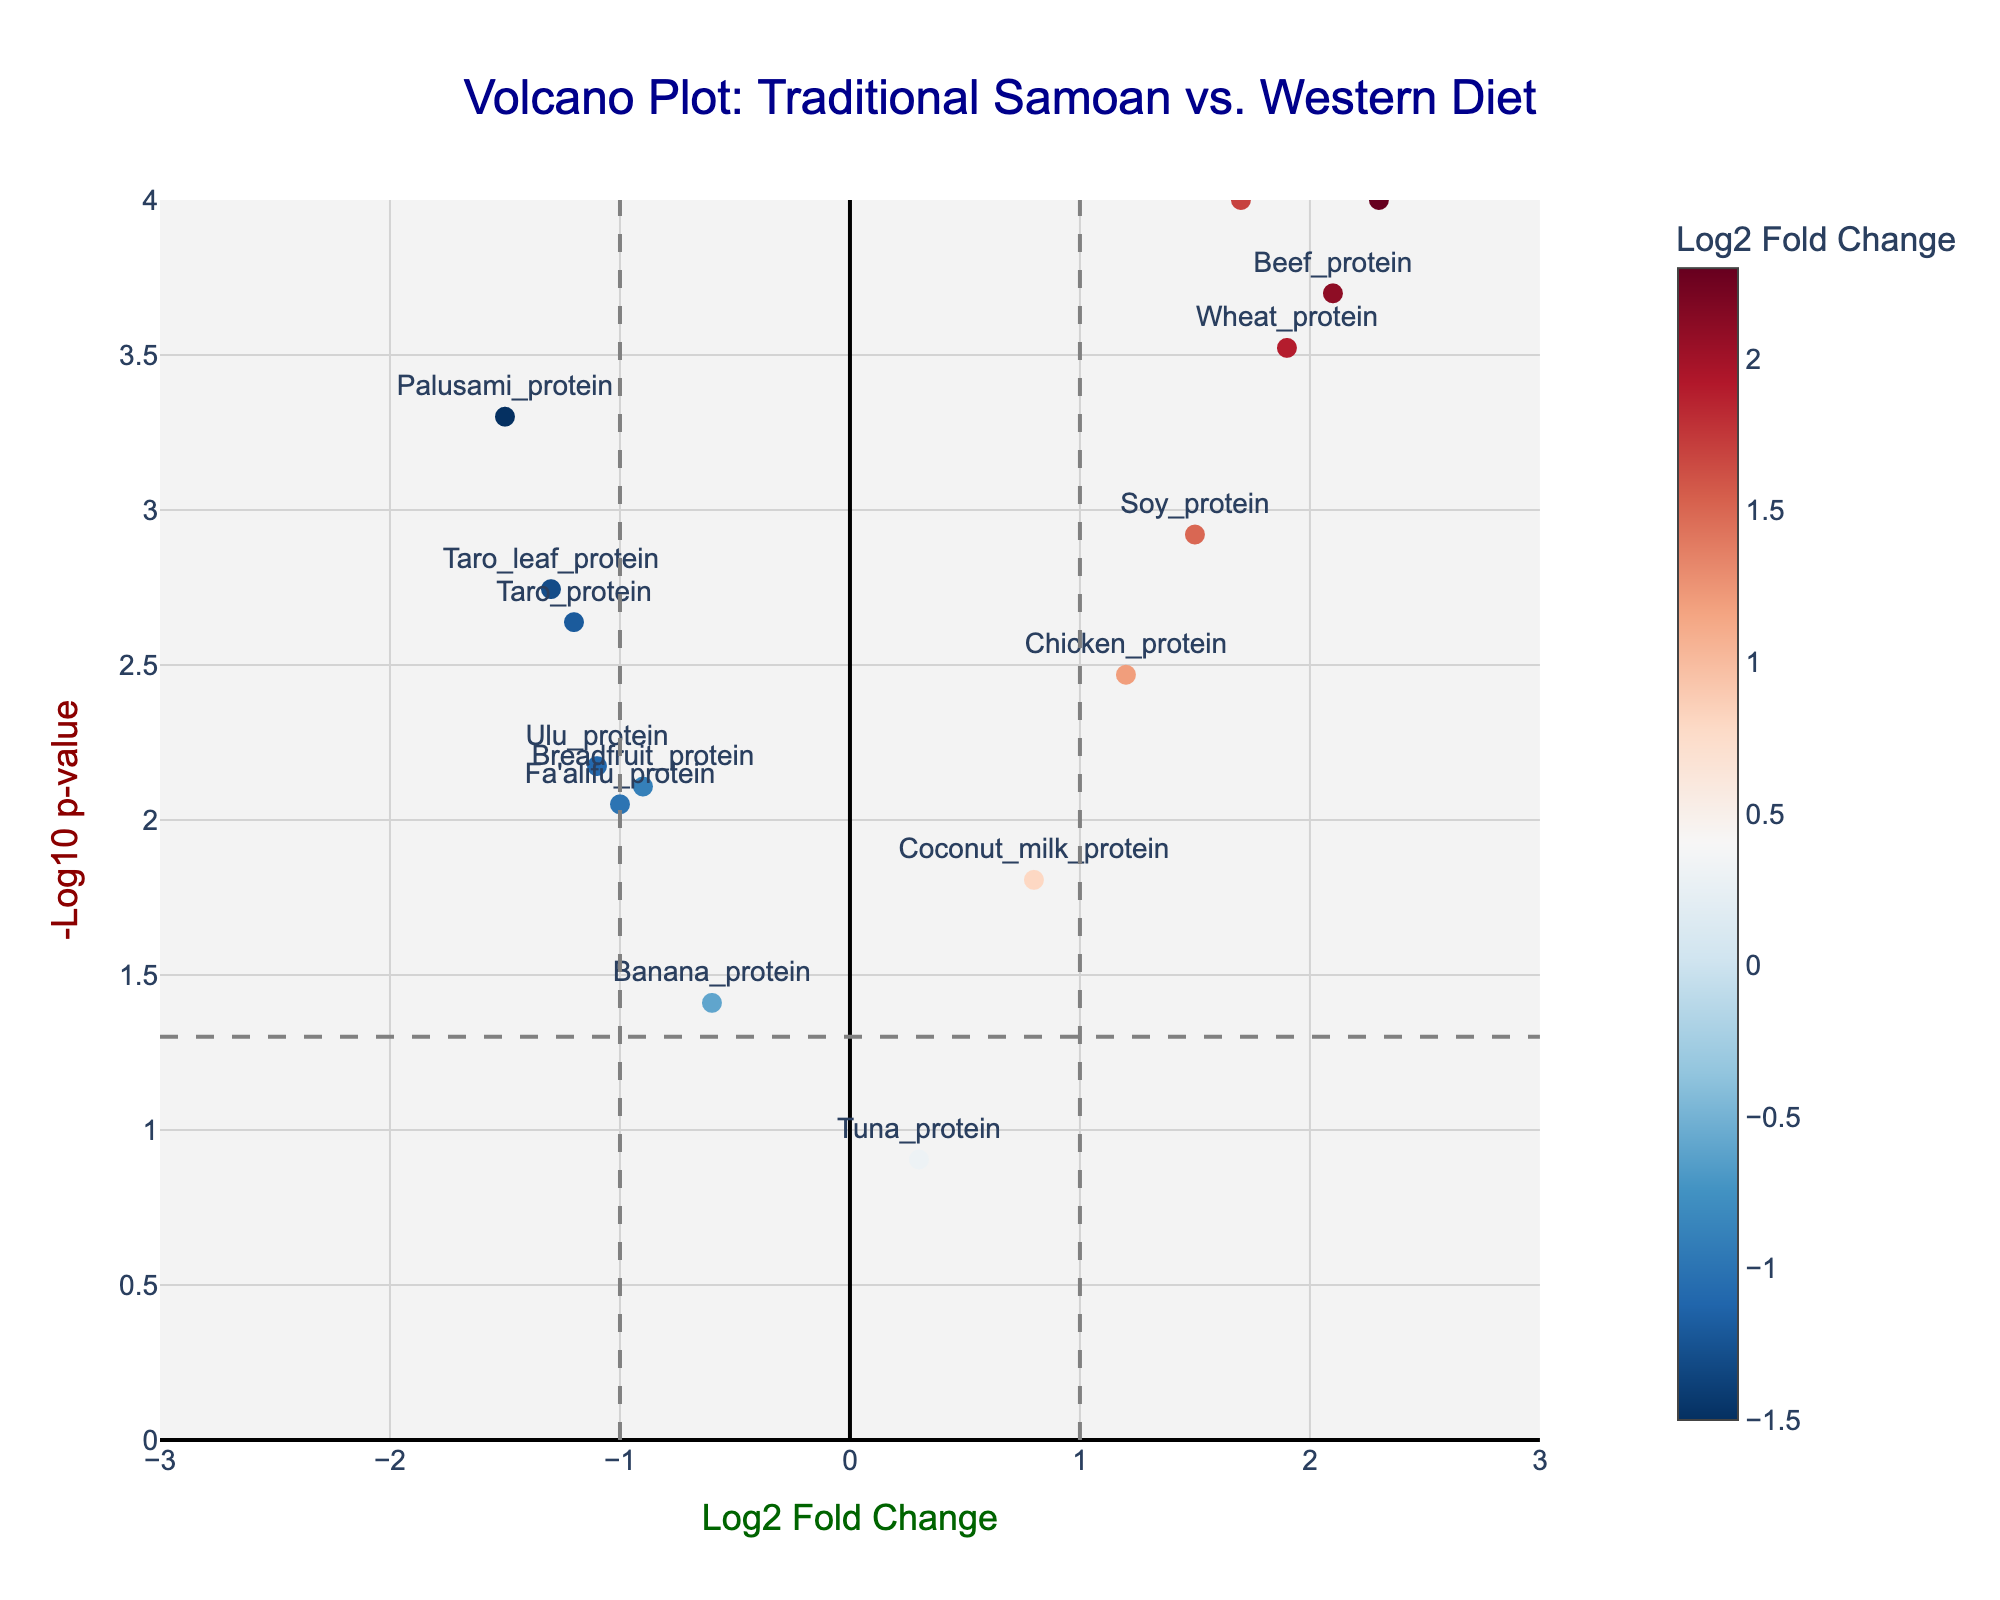What is the title of the plot? The title of the plot is located at the top center of the figure. It typically provides a summary of what the plot represents.
Answer: Volcano Plot: Traditional Samoan vs. Western Diet What do the colors of the data points represent? The colors of the data points indicate the log2 fold change values. Points are colored on a scale from blue to red, with the color bar on the right providing the scale for interpretation.
Answer: Log2 Fold Change How many proteins have a p-value less than 0.05? To answer this, count the number of data points above the horizontal dashed line, which represents the p-value threshold of 0.05 (-log10(0.05) ≈ 1.3).
Answer: 13 Which protein has the highest log2 fold change? Check the data point farthest to the right along the x-axis (check the hover text or labels if available).
Answer: Processed_cheese_protein Which traditional Samoan protein has the lowest log2 fold change? Focus on proteins that typically are part of the traditional Samoan diet and find the one with the lowest log2 fold change value (farthest left on the x-axis).
Answer: Palusami_protein How many proteins have a log2 fold change greater than 1? Count the data points to the right of the vertical dashed line at x = 1.
Answer: 5 What is the -log10(p-value) of Pork_protein? Locate the label for Pork_protein and read the -log10(p-value) (hovering over the point might help).
Answer: Approximately 4 (exact value derived from p-value of 0.0001) Which protein has the closest p-value to 0.05? Identify the point closest to the horizontal dashed line for -log10(p-value) = 1.3. Check the hover text or labels if needed.
Answer: Banana_protein Compare the log2 fold change values of Chicken_protein and Taro_protein. Find the data points for Chicken_protein and Taro_protein; note their log2 fold change values. Compare these values directly.
Answer: Chicken_protein has a higher log2 fold change 